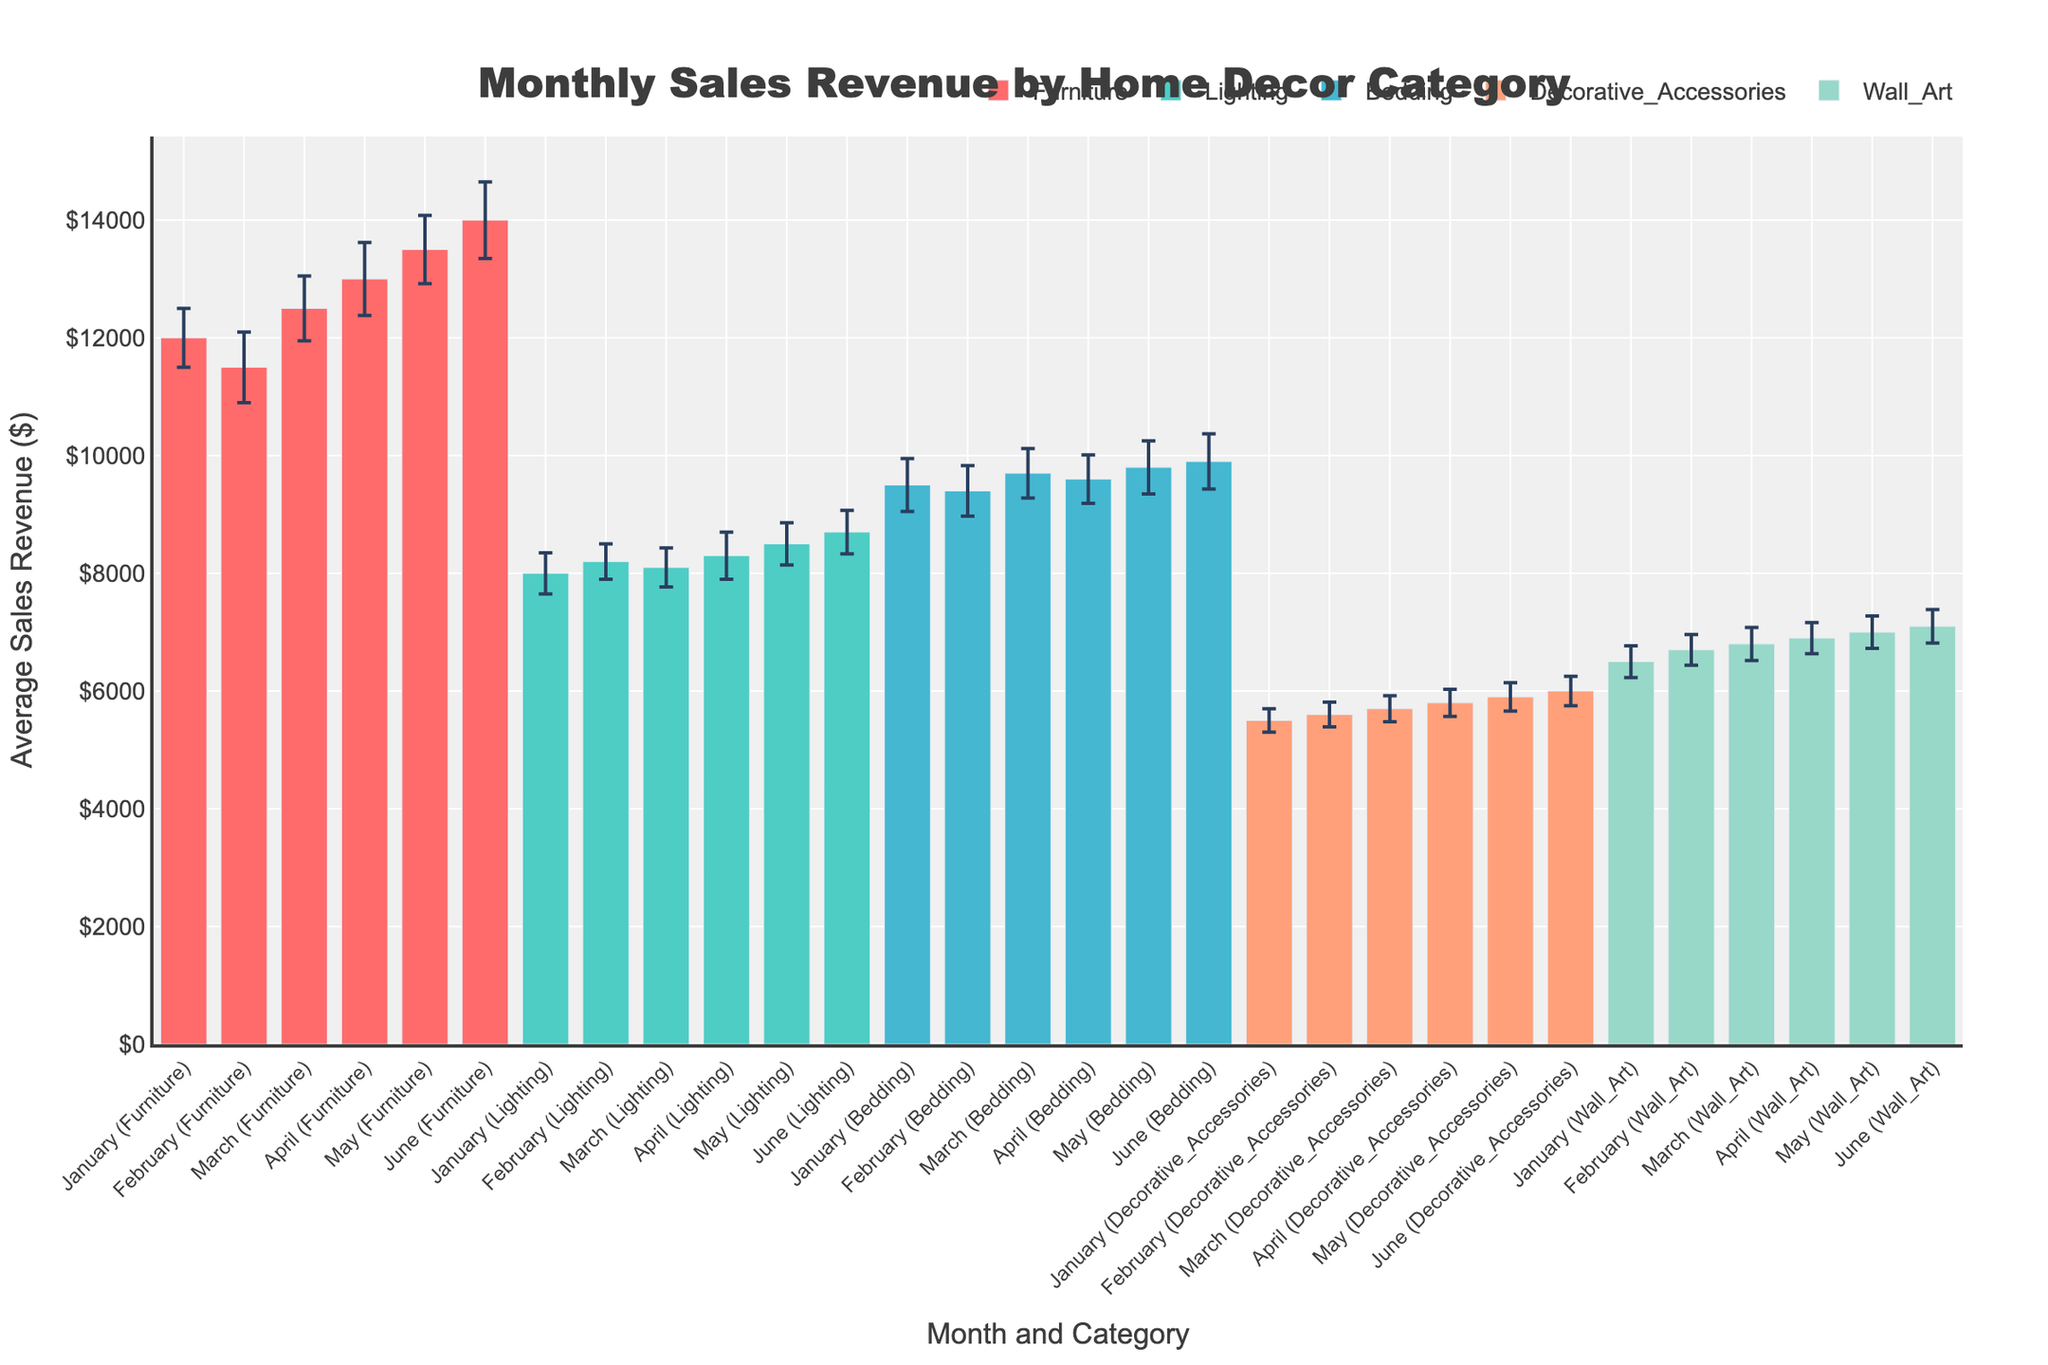What is the title of the chart? The title of the chart is located at the top of the figure. Titles are typically large and prominent to indicate the main topic or focus of the chart.
Answer: Monthly Sales Revenue by Home Decor Category What are the categories shown in the chart? The categories are indicated by different colored bars on the chart. Each category is associated with a distinct color and represented in the legend at the top right of the chart.
Answer: Furniture, Lighting, Bedding, Decorative Accessories, Wall Art Which month shows the highest average sales revenue for Lighting? To find the highest average sales revenue for Lighting, look at the bars corresponding to Lighting and identify the month with the highest bar.
Answer: June What is the range of average sales revenue for Wall Art items from January to June? The range is computed by identifying the smallest and largest values of average sales revenue for Wall Art items in the given months and subtracting the smallest from the largest. The sales values are shown on the y-axis.
Answer: $7100 - $6500 = $600 Which category has the highest overall average sales revenue in June? Compare the height of the bars for each category in June. The highest bar represents the category with the highest revenue.
Answer: Furniture What is the average sales revenue for Bedding in April, and what is its standard deviation? Look for the bar corresponding to Bedding in April and note its height for the average sales revenue, and check the error bars for the standard deviation.
Answer: $9600, $410 Which category has the smallest monthly variation in average sales revenue, considering their standard deviations? Analyze the error bars for each category over multiple months and identify the category with consistently smaller error bars, indicating less variation.
Answer: Decorative Accessories What is the difference in average sales revenue between Furniture and Wall Art for the month of May? Subtract the average sales revenue of Wall Art in May from the average sales revenue of Furniture in May, referring to the bar heights for these categories in the given month.
Answer: $13500 - $7000 = $6500 Identify the category with the least sales revenue in January and specify the value. Look at the bars for each category in January and identify the lowest one.
Answer: Decorative Accessories, $5500 